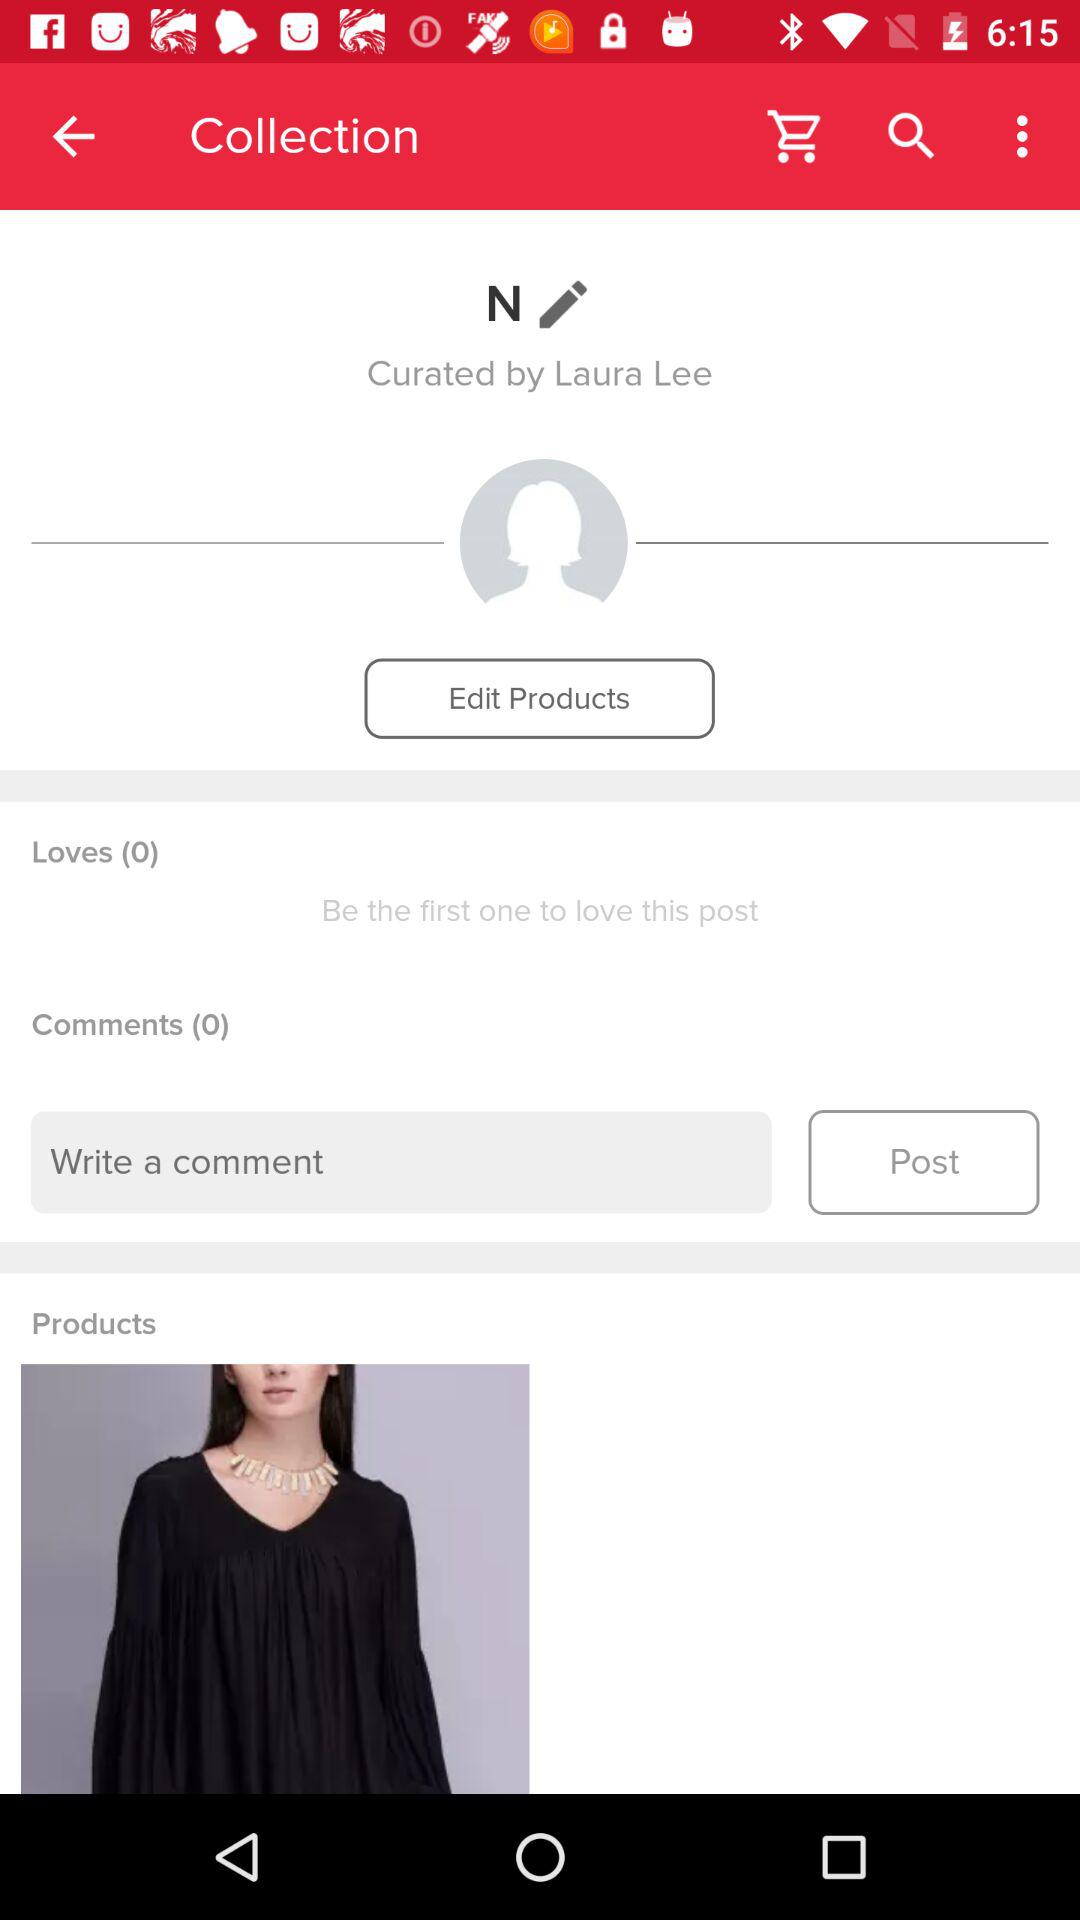How many more products are there than loves?
Answer the question using a single word or phrase. 1 